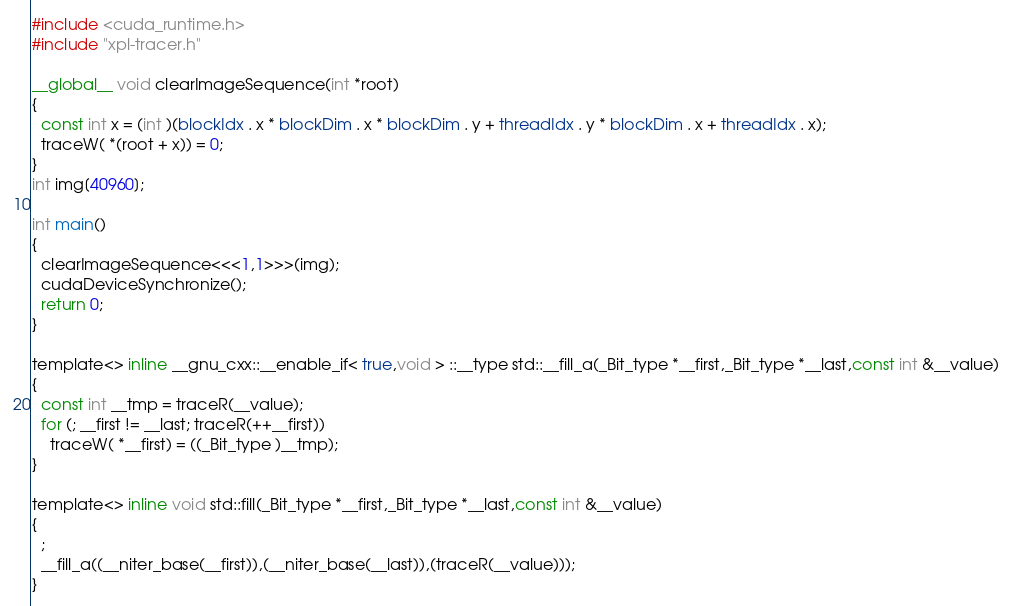<code> <loc_0><loc_0><loc_500><loc_500><_Cuda_>#include <cuda_runtime.h>
#include "xpl-tracer.h"

__global__ void clearImageSequence(int *root)
{
  const int x = (int )(blockIdx . x * blockDim . x * blockDim . y + threadIdx . y * blockDim . x + threadIdx . x);
  traceW( *(root + x)) = 0;
}
int img[40960];

int main()
{
  clearImageSequence<<<1,1>>>(img);
  cudaDeviceSynchronize();
  return 0;
}

template<> inline __gnu_cxx::__enable_if< true,void > ::__type std::__fill_a(_Bit_type *__first,_Bit_type *__last,const int &__value)
{
  const int __tmp = traceR(__value);
  for (; __first != __last; traceR(++__first)) 
    traceW( *__first) = ((_Bit_type )__tmp);
}

template<> inline void std::fill(_Bit_type *__first,_Bit_type *__last,const int &__value)
{
  ;
  __fill_a((__niter_base(__first)),(__niter_base(__last)),(traceR(__value)));
}
</code> 